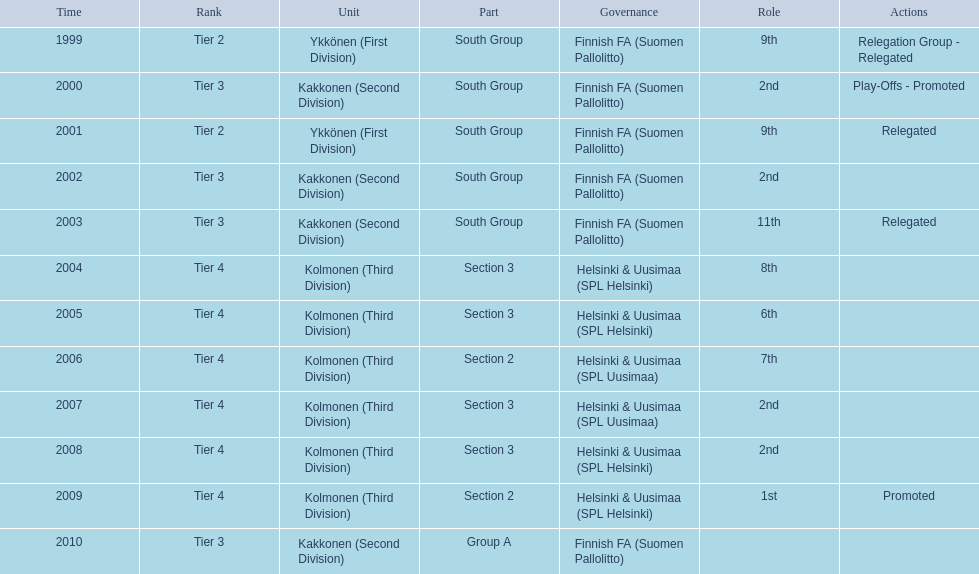What position did this team get after getting 9th place in 1999? 2nd. 